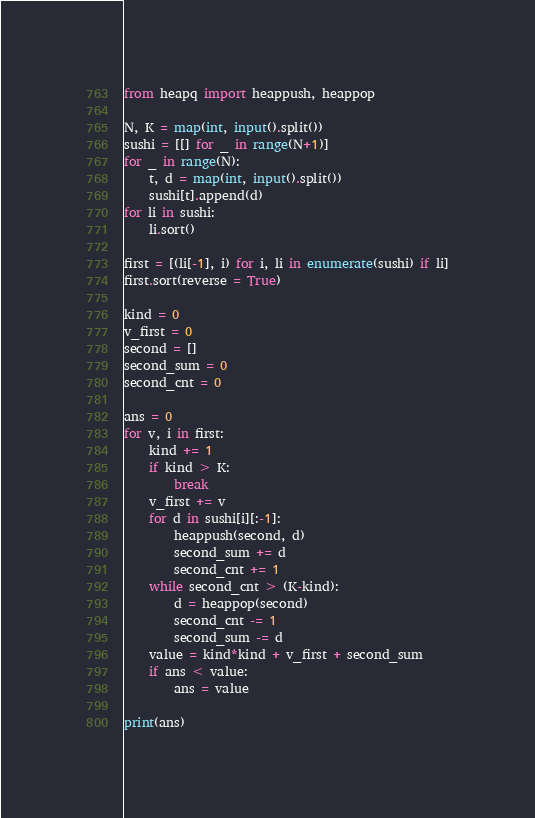Convert code to text. <code><loc_0><loc_0><loc_500><loc_500><_Python_>from heapq import heappush, heappop

N, K = map(int, input().split())
sushi = [[] for _ in range(N+1)]
for _ in range(N):
    t, d = map(int, input().split())
    sushi[t].append(d)
for li in sushi:
    li.sort()

first = [(li[-1], i) for i, li in enumerate(sushi) if li]
first.sort(reverse = True)

kind = 0
v_first = 0
second = []
second_sum = 0
second_cnt = 0

ans = 0
for v, i in first:
    kind += 1
    if kind > K:
        break
    v_first += v
    for d in sushi[i][:-1]:
        heappush(second, d)
        second_sum += d
        second_cnt += 1
    while second_cnt > (K-kind):
        d = heappop(second)
        second_cnt -= 1
        second_sum -= d
    value = kind*kind + v_first + second_sum
    if ans < value:
        ans = value

print(ans)</code> 